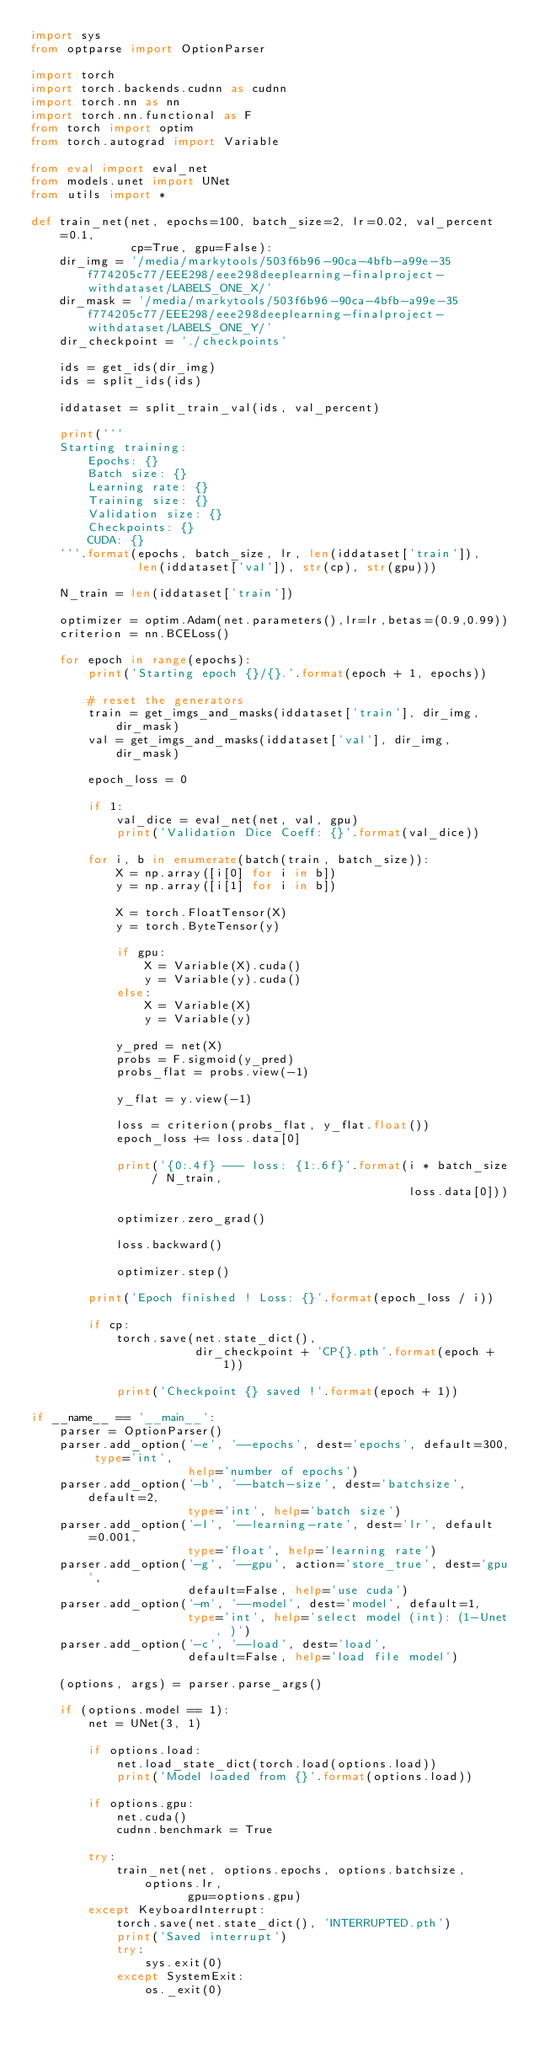Convert code to text. <code><loc_0><loc_0><loc_500><loc_500><_Python_>import sys
from optparse import OptionParser

import torch
import torch.backends.cudnn as cudnn
import torch.nn as nn
import torch.nn.functional as F
from torch import optim
from torch.autograd import Variable

from eval import eval_net
from models.unet import UNet
from utils import *

def train_net(net, epochs=100, batch_size=2, lr=0.02, val_percent=0.1,
              cp=True, gpu=False):
    dir_img = '/media/markytools/503f6b96-90ca-4bfb-a99e-35f774205c77/EEE298/eee298deeplearning-finalproject-withdataset/LABELS_ONE_X/'
    dir_mask = '/media/markytools/503f6b96-90ca-4bfb-a99e-35f774205c77/EEE298/eee298deeplearning-finalproject-withdataset/LABELS_ONE_Y/'
    dir_checkpoint = './checkpoints'

    ids = get_ids(dir_img)
    ids = split_ids(ids)

    iddataset = split_train_val(ids, val_percent)

    print('''
    Starting training:
        Epochs: {}
        Batch size: {}
        Learning rate: {}
        Training size: {}
        Validation size: {}
        Checkpoints: {}
        CUDA: {}
    '''.format(epochs, batch_size, lr, len(iddataset['train']),
               len(iddataset['val']), str(cp), str(gpu)))

    N_train = len(iddataset['train'])

    optimizer = optim.Adam(net.parameters(),lr=lr,betas=(0.9,0.99))
    criterion = nn.BCELoss()

    for epoch in range(epochs):
        print('Starting epoch {}/{}.'.format(epoch + 1, epochs))

        # reset the generators
        train = get_imgs_and_masks(iddataset['train'], dir_img, dir_mask)
        val = get_imgs_and_masks(iddataset['val'], dir_img, dir_mask)

        epoch_loss = 0

        if 1:
            val_dice = eval_net(net, val, gpu)
            print('Validation Dice Coeff: {}'.format(val_dice))

        for i, b in enumerate(batch(train, batch_size)):
            X = np.array([i[0] for i in b])
            y = np.array([i[1] for i in b])

            X = torch.FloatTensor(X)
            y = torch.ByteTensor(y)

            if gpu:
                X = Variable(X).cuda()
                y = Variable(y).cuda()
            else:
                X = Variable(X)
                y = Variable(y)

            y_pred = net(X)
            probs = F.sigmoid(y_pred)
            probs_flat = probs.view(-1)

            y_flat = y.view(-1)

            loss = criterion(probs_flat, y_flat.float())
            epoch_loss += loss.data[0]

            print('{0:.4f} --- loss: {1:.6f}'.format(i * batch_size / N_train,
                                                     loss.data[0]))

            optimizer.zero_grad()

            loss.backward()

            optimizer.step()

        print('Epoch finished ! Loss: {}'.format(epoch_loss / i))

        if cp:
            torch.save(net.state_dict(),
                       dir_checkpoint + 'CP{}.pth'.format(epoch + 1))

            print('Checkpoint {} saved !'.format(epoch + 1))

if __name__ == '__main__':
    parser = OptionParser()
    parser.add_option('-e', '--epochs', dest='epochs', default=300, type='int',
                      help='number of epochs')
    parser.add_option('-b', '--batch-size', dest='batchsize', default=2,
                      type='int', help='batch size')
    parser.add_option('-l', '--learning-rate', dest='lr', default=0.001,
                      type='float', help='learning rate')
    parser.add_option('-g', '--gpu', action='store_true', dest='gpu',
                      default=False, help='use cuda')
    parser.add_option('-m', '--model', dest='model', default=1,
                      type='int', help='select model (int): (1-Unet, )')
    parser.add_option('-c', '--load', dest='load',
                      default=False, help='load file model')

    (options, args) = parser.parse_args()

    if (options.model == 1):
        net = UNet(3, 1)

        if options.load:
            net.load_state_dict(torch.load(options.load))
            print('Model loaded from {}'.format(options.load))

        if options.gpu:
            net.cuda()
            cudnn.benchmark = True

        try:
            train_net(net, options.epochs, options.batchsize, options.lr,
                      gpu=options.gpu)
        except KeyboardInterrupt:
            torch.save(net.state_dict(), 'INTERRUPTED.pth')
            print('Saved interrupt')
            try:
                sys.exit(0)
            except SystemExit:
                os._exit(0)
</code> 